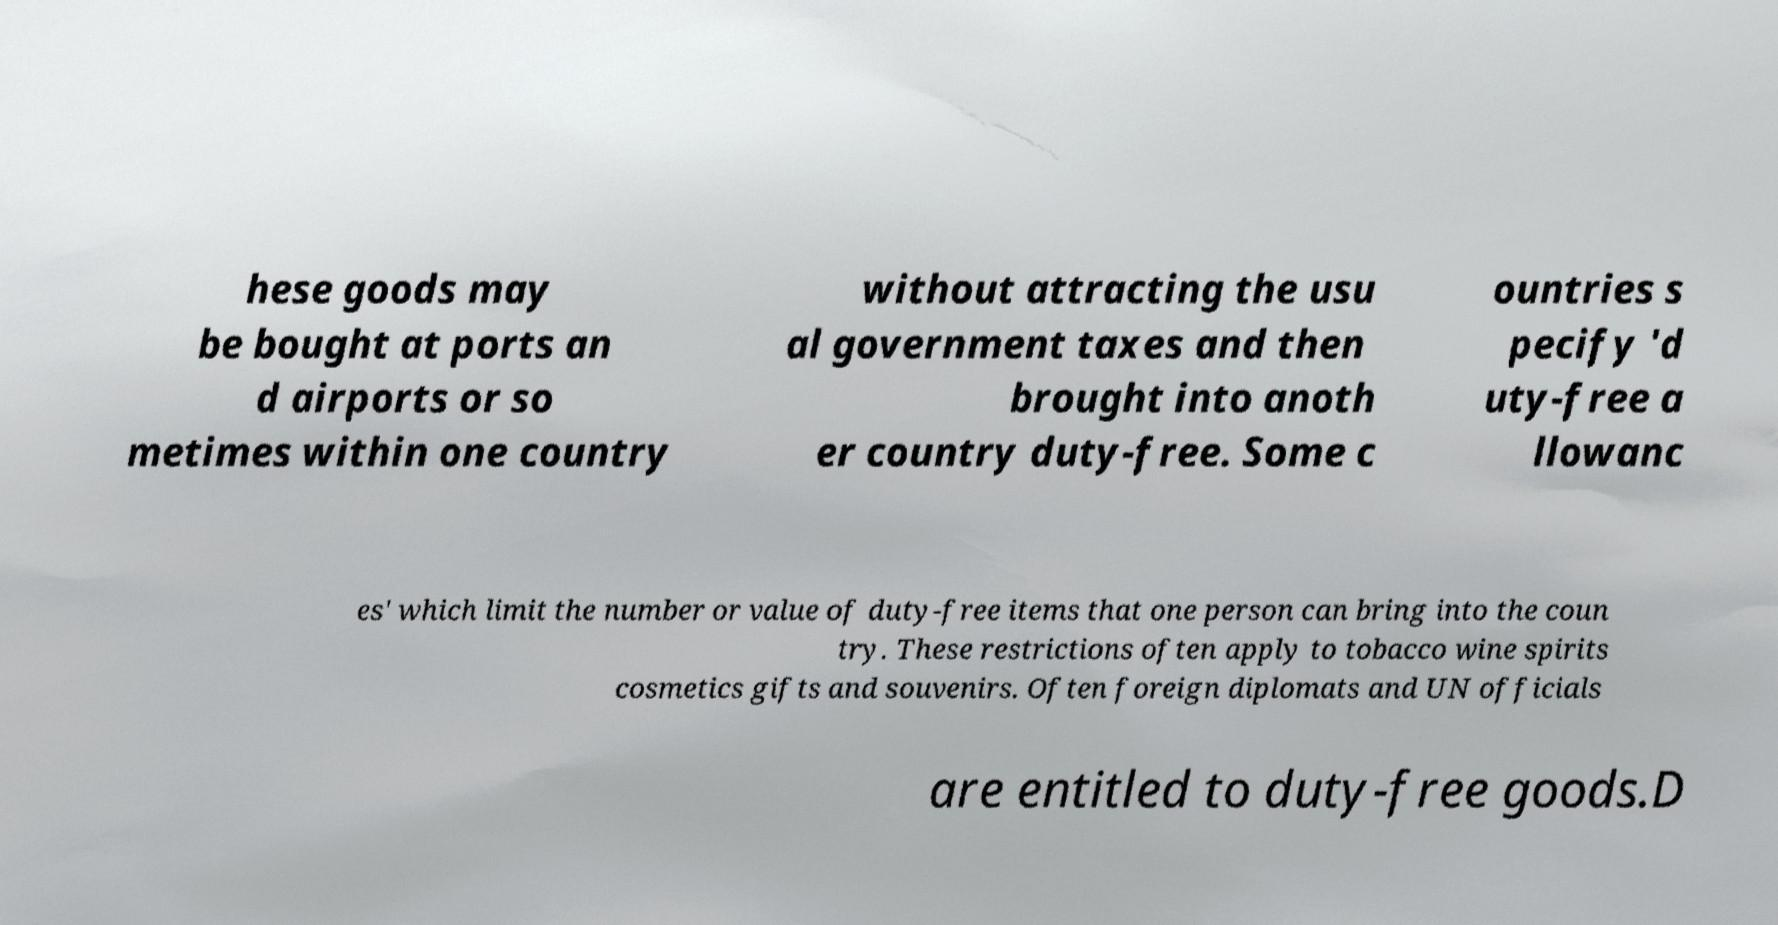For documentation purposes, I need the text within this image transcribed. Could you provide that? hese goods may be bought at ports an d airports or so metimes within one country without attracting the usu al government taxes and then brought into anoth er country duty-free. Some c ountries s pecify 'd uty-free a llowanc es' which limit the number or value of duty-free items that one person can bring into the coun try. These restrictions often apply to tobacco wine spirits cosmetics gifts and souvenirs. Often foreign diplomats and UN officials are entitled to duty-free goods.D 